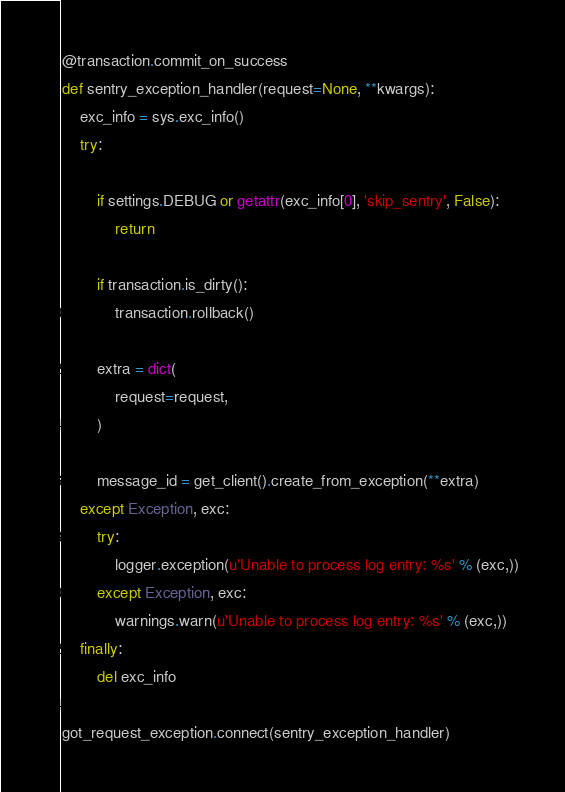Convert code to text. <code><loc_0><loc_0><loc_500><loc_500><_Python_>
@transaction.commit_on_success
def sentry_exception_handler(request=None, **kwargs):
    exc_info = sys.exc_info()
    try:

        if settings.DEBUG or getattr(exc_info[0], 'skip_sentry', False):
            return

        if transaction.is_dirty():
            transaction.rollback()

        extra = dict(
            request=request,
        )
        
        message_id = get_client().create_from_exception(**extra)
    except Exception, exc:
        try:
            logger.exception(u'Unable to process log entry: %s' % (exc,))
        except Exception, exc:
            warnings.warn(u'Unable to process log entry: %s' % (exc,))
    finally:
        del exc_info

got_request_exception.connect(sentry_exception_handler)

</code> 